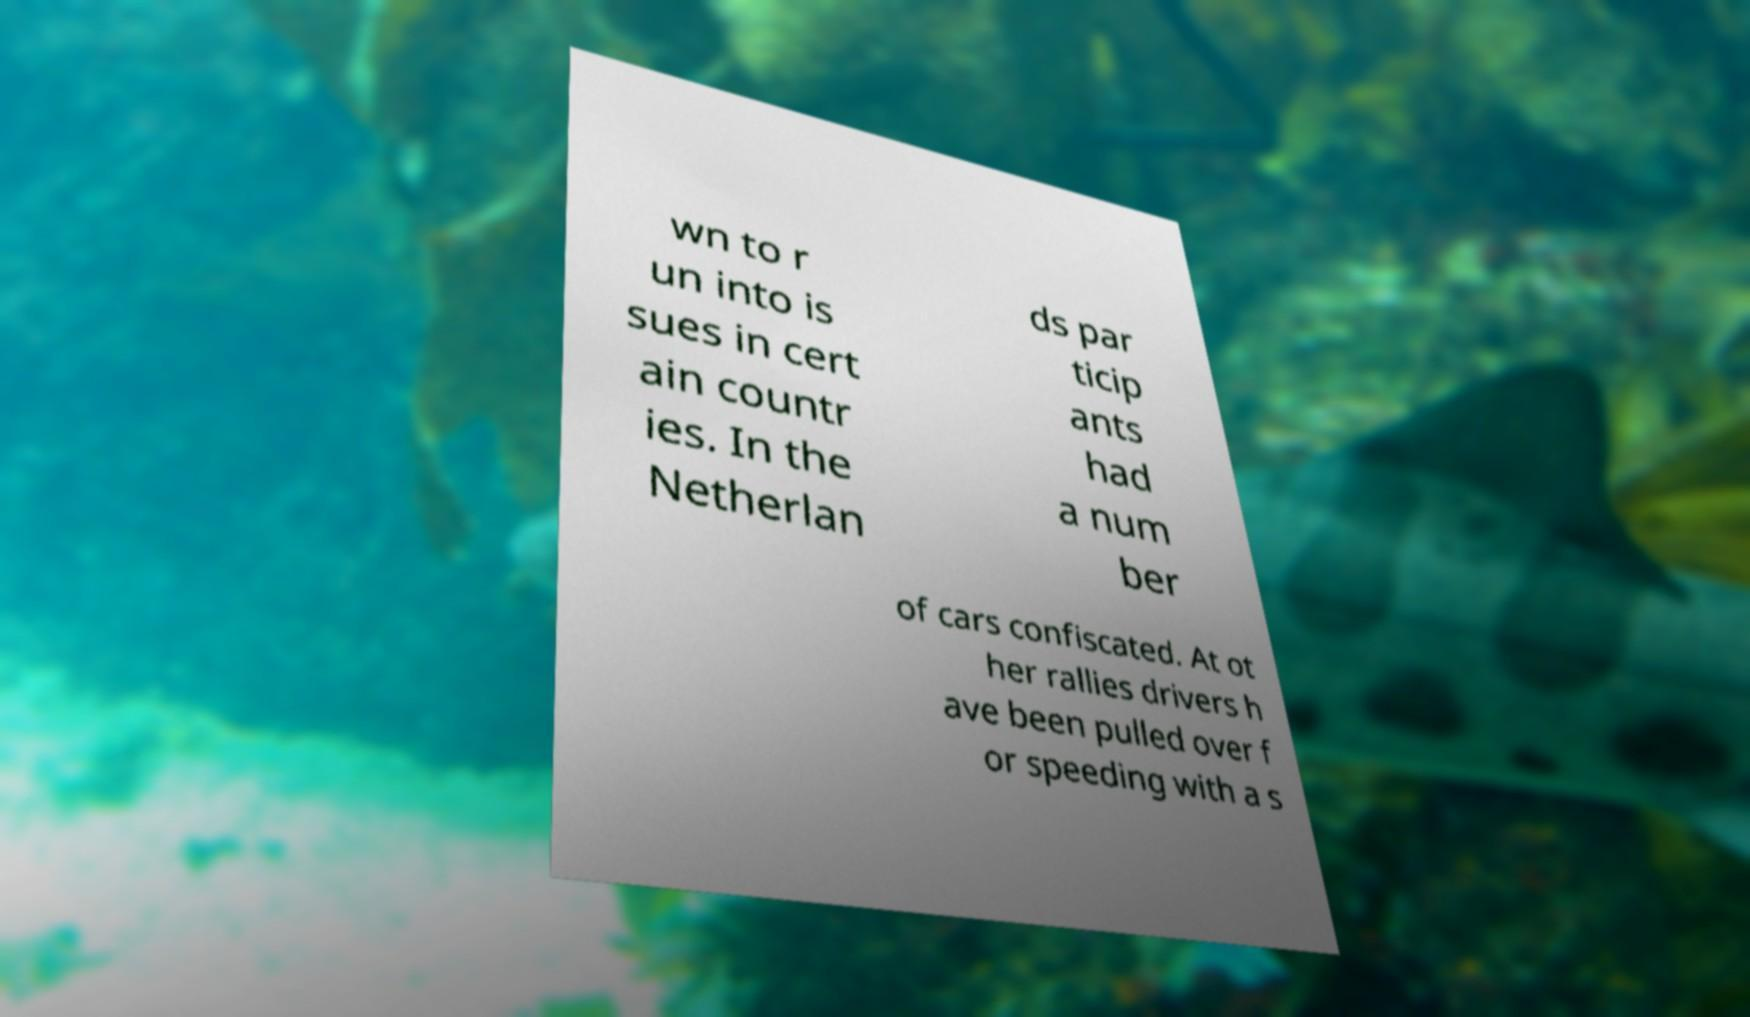Can you read and provide the text displayed in the image?This photo seems to have some interesting text. Can you extract and type it out for me? wn to r un into is sues in cert ain countr ies. In the Netherlan ds par ticip ants had a num ber of cars confiscated. At ot her rallies drivers h ave been pulled over f or speeding with a s 